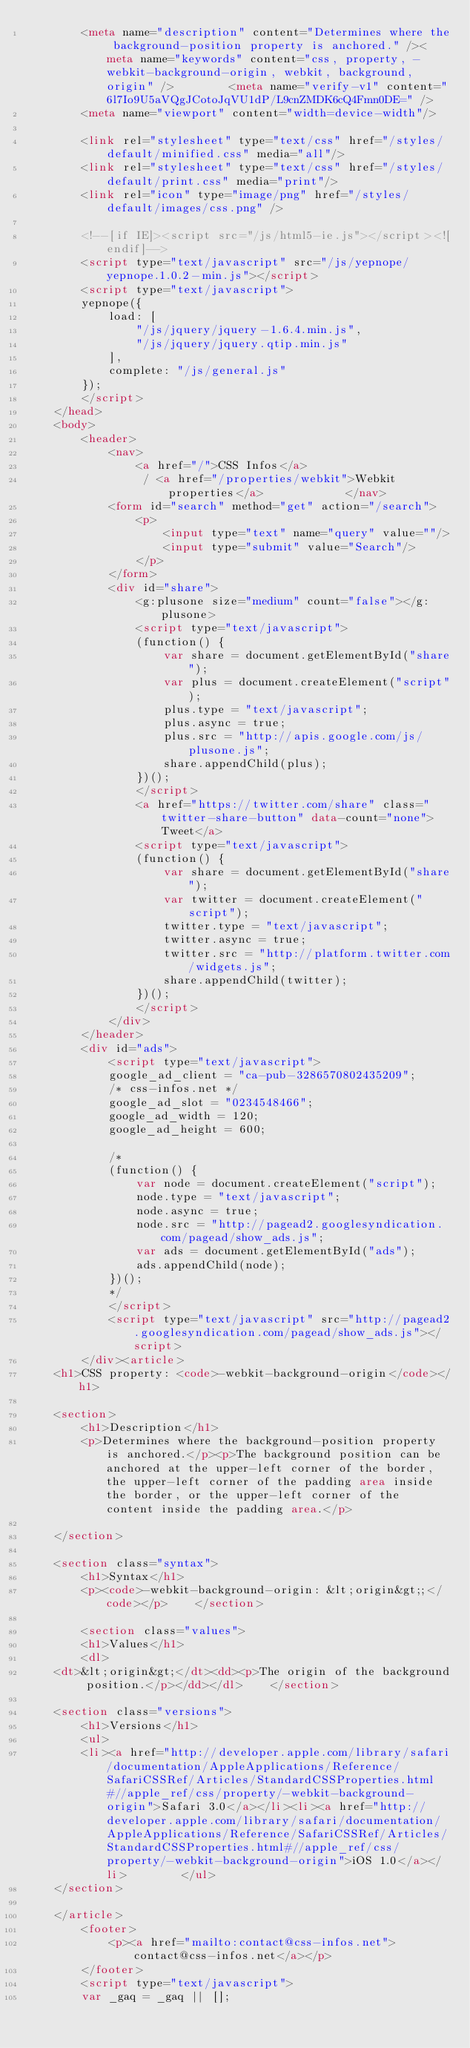Convert code to text. <code><loc_0><loc_0><loc_500><loc_500><_HTML_>        <meta name="description" content="Determines where the background-position property is anchored." /><meta name="keywords" content="css, property, -webkit-background-origin, webkit, background, origin" />        <meta name="verify-v1" content="6l7Io9U5aVQgJCotoJqVU1dP/L9cnZMDK6cQ4Fmn0DE=" />
        <meta name="viewport" content="width=device-width"/>

        <link rel="stylesheet" type="text/css" href="/styles/default/minified.css" media="all"/>
        <link rel="stylesheet" type="text/css" href="/styles/default/print.css" media="print"/>
        <link rel="icon" type="image/png" href="/styles/default/images/css.png" />

        <!--[if IE]><script src="/js/html5-ie.js"></script><![endif]-->
        <script type="text/javascript" src="/js/yepnope/yepnope.1.0.2-min.js"></script>
        <script type="text/javascript">
        yepnope({
            load: [
                "/js/jquery/jquery-1.6.4.min.js",
                "/js/jquery/jquery.qtip.min.js"
            ],
            complete: "/js/general.js"
        });
        </script>
    </head>
    <body>
        <header>
            <nav>
                <a href="/">CSS Infos</a>
                 / <a href="/properties/webkit">Webkit properties</a>            </nav>
            <form id="search" method="get" action="/search">
                <p>
                    <input type="text" name="query" value=""/>
                    <input type="submit" value="Search"/>
                </p>
            </form>
            <div id="share">
                <g:plusone size="medium" count="false"></g:plusone>
                <script type="text/javascript">
                (function() {
                    var share = document.getElementById("share");
                    var plus = document.createElement("script");
                    plus.type = "text/javascript";
                    plus.async = true;
                    plus.src = "http://apis.google.com/js/plusone.js";
                    share.appendChild(plus);
                })();
                </script>
                <a href="https://twitter.com/share" class="twitter-share-button" data-count="none">Tweet</a>
                <script type="text/javascript">
                (function() {
                    var share = document.getElementById("share");
                    var twitter = document.createElement("script");
                    twitter.type = "text/javascript";
                    twitter.async = true;
                    twitter.src = "http://platform.twitter.com/widgets.js";
                    share.appendChild(twitter);
                })();
                </script>
            </div>
        </header>
        <div id="ads">
            <script type="text/javascript">
            google_ad_client = "ca-pub-3286570802435209";
            /* css-infos.net */
            google_ad_slot = "0234548466";
            google_ad_width = 120;
            google_ad_height = 600;

            /*
            (function() {
                var node = document.createElement("script");
                node.type = "text/javascript";
                node.async = true;
                node.src = "http://pagead2.googlesyndication.com/pagead/show_ads.js";
                var ads = document.getElementById("ads");
                ads.appendChild(node);
            })();
            */
            </script>
            <script type="text/javascript" src="http://pagead2.googlesyndication.com/pagead/show_ads.js"></script>
        </div><article>
    <h1>CSS property: <code>-webkit-background-origin</code></h1>

    <section>
        <h1>Description</h1>
        <p>Determines where the background-position property is anchored.</p><p>The background position can be anchored at the upper-left corner of the border, the upper-left corner of the padding area inside the border, or the upper-left corner of the content inside the padding area.</p>

    </section>

    <section class="syntax">
        <h1>Syntax</h1>
        <p><code>-webkit-background-origin: &lt;origin&gt;;</code></p>    </section>

        <section class="values">
        <h1>Values</h1>
        <dl>
    <dt>&lt;origin&gt;</dt><dd><p>The origin of the background position.</p></dd></dl>    </section>
    
    <section class="versions">
        <h1>Versions</h1>
        <ul>
        <li><a href="http://developer.apple.com/library/safari/documentation/AppleApplications/Reference/SafariCSSRef/Articles/StandardCSSProperties.html#//apple_ref/css/property/-webkit-background-origin">Safari 3.0</a></li><li><a href="http://developer.apple.com/library/safari/documentation/AppleApplications/Reference/SafariCSSRef/Articles/StandardCSSProperties.html#//apple_ref/css/property/-webkit-background-origin">iOS 1.0</a></li>        </ul>
    </section>

    </article>
        <footer>
            <p><a href="mailto:contact@css-infos.net">contact@css-infos.net</a></p>
        </footer>
        <script type="text/javascript"> 
        var _gaq = _gaq || [];</code> 